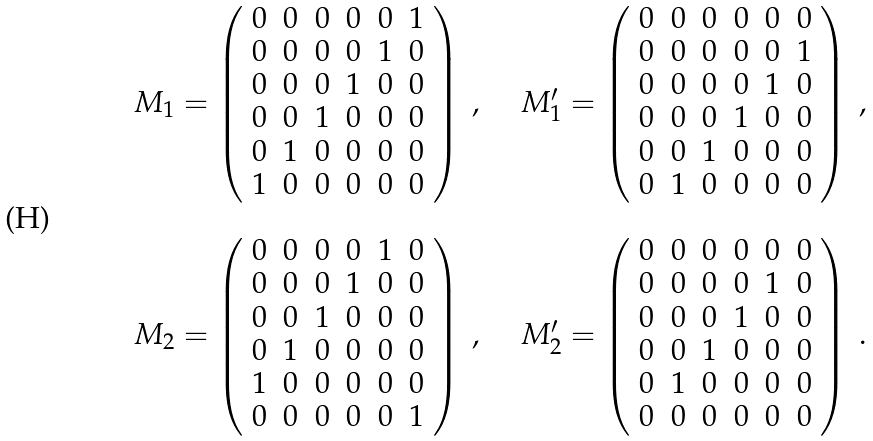Convert formula to latex. <formula><loc_0><loc_0><loc_500><loc_500>\begin{array} { c c c } M _ { 1 } = \left ( \begin{array} { c c c c c c } 0 & 0 & 0 & 0 & 0 & 1 \\ 0 & 0 & 0 & 0 & 1 & 0 \\ 0 & 0 & 0 & 1 & 0 & 0 \\ 0 & 0 & 1 & 0 & 0 & 0 \\ 0 & 1 & 0 & 0 & 0 & 0 \\ 1 & 0 & 0 & 0 & 0 & 0 \end{array} \right ) \ , & \ & M _ { 1 } ^ { \prime } = \left ( \begin{array} { c c c c c c } 0 & 0 & 0 & 0 & 0 & 0 \\ 0 & 0 & 0 & 0 & 0 & 1 \\ 0 & 0 & 0 & 0 & 1 & 0 \\ 0 & 0 & 0 & 1 & 0 & 0 \\ 0 & 0 & 1 & 0 & 0 & 0 \\ 0 & 1 & 0 & 0 & 0 & 0 \end{array} \right ) \ , \\ \ & \ & \ \\ M _ { 2 } = \left ( \begin{array} { c c c c c c } 0 & 0 & 0 & 0 & 1 & 0 \\ 0 & 0 & 0 & 1 & 0 & 0 \\ 0 & 0 & 1 & 0 & 0 & 0 \\ 0 & 1 & 0 & 0 & 0 & 0 \\ 1 & 0 & 0 & 0 & 0 & 0 \\ 0 & 0 & 0 & 0 & 0 & 1 \end{array} \right ) \ , & \ & M _ { 2 } ^ { \prime } = \left ( \begin{array} { c c c c c c } 0 & 0 & 0 & 0 & 0 & 0 \\ 0 & 0 & 0 & 0 & 1 & 0 \\ 0 & 0 & 0 & 1 & 0 & 0 \\ 0 & 0 & 1 & 0 & 0 & 0 \\ 0 & 1 & 0 & 0 & 0 & 0 \\ 0 & 0 & 0 & 0 & 0 & 0 \end{array} \right ) \ . \end{array}</formula> 